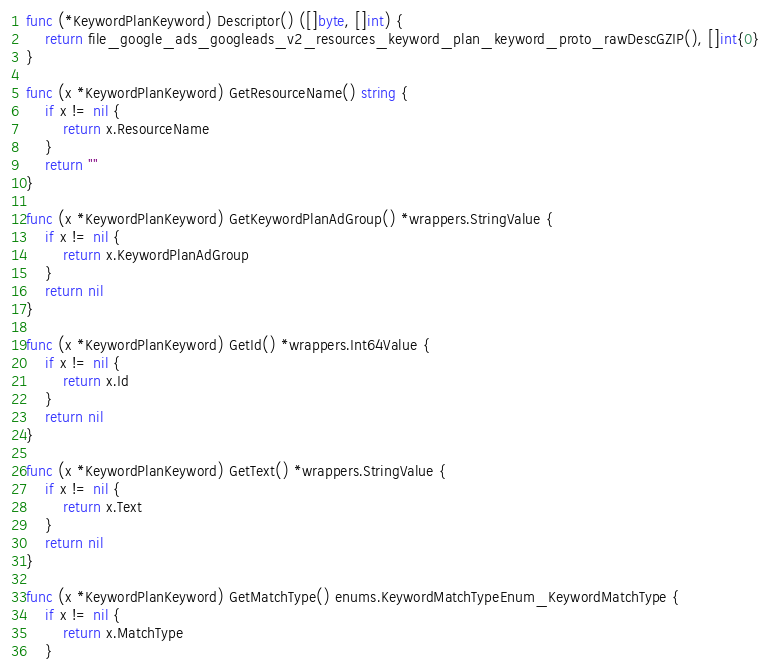<code> <loc_0><loc_0><loc_500><loc_500><_Go_>func (*KeywordPlanKeyword) Descriptor() ([]byte, []int) {
	return file_google_ads_googleads_v2_resources_keyword_plan_keyword_proto_rawDescGZIP(), []int{0}
}

func (x *KeywordPlanKeyword) GetResourceName() string {
	if x != nil {
		return x.ResourceName
	}
	return ""
}

func (x *KeywordPlanKeyword) GetKeywordPlanAdGroup() *wrappers.StringValue {
	if x != nil {
		return x.KeywordPlanAdGroup
	}
	return nil
}

func (x *KeywordPlanKeyword) GetId() *wrappers.Int64Value {
	if x != nil {
		return x.Id
	}
	return nil
}

func (x *KeywordPlanKeyword) GetText() *wrappers.StringValue {
	if x != nil {
		return x.Text
	}
	return nil
}

func (x *KeywordPlanKeyword) GetMatchType() enums.KeywordMatchTypeEnum_KeywordMatchType {
	if x != nil {
		return x.MatchType
	}</code> 